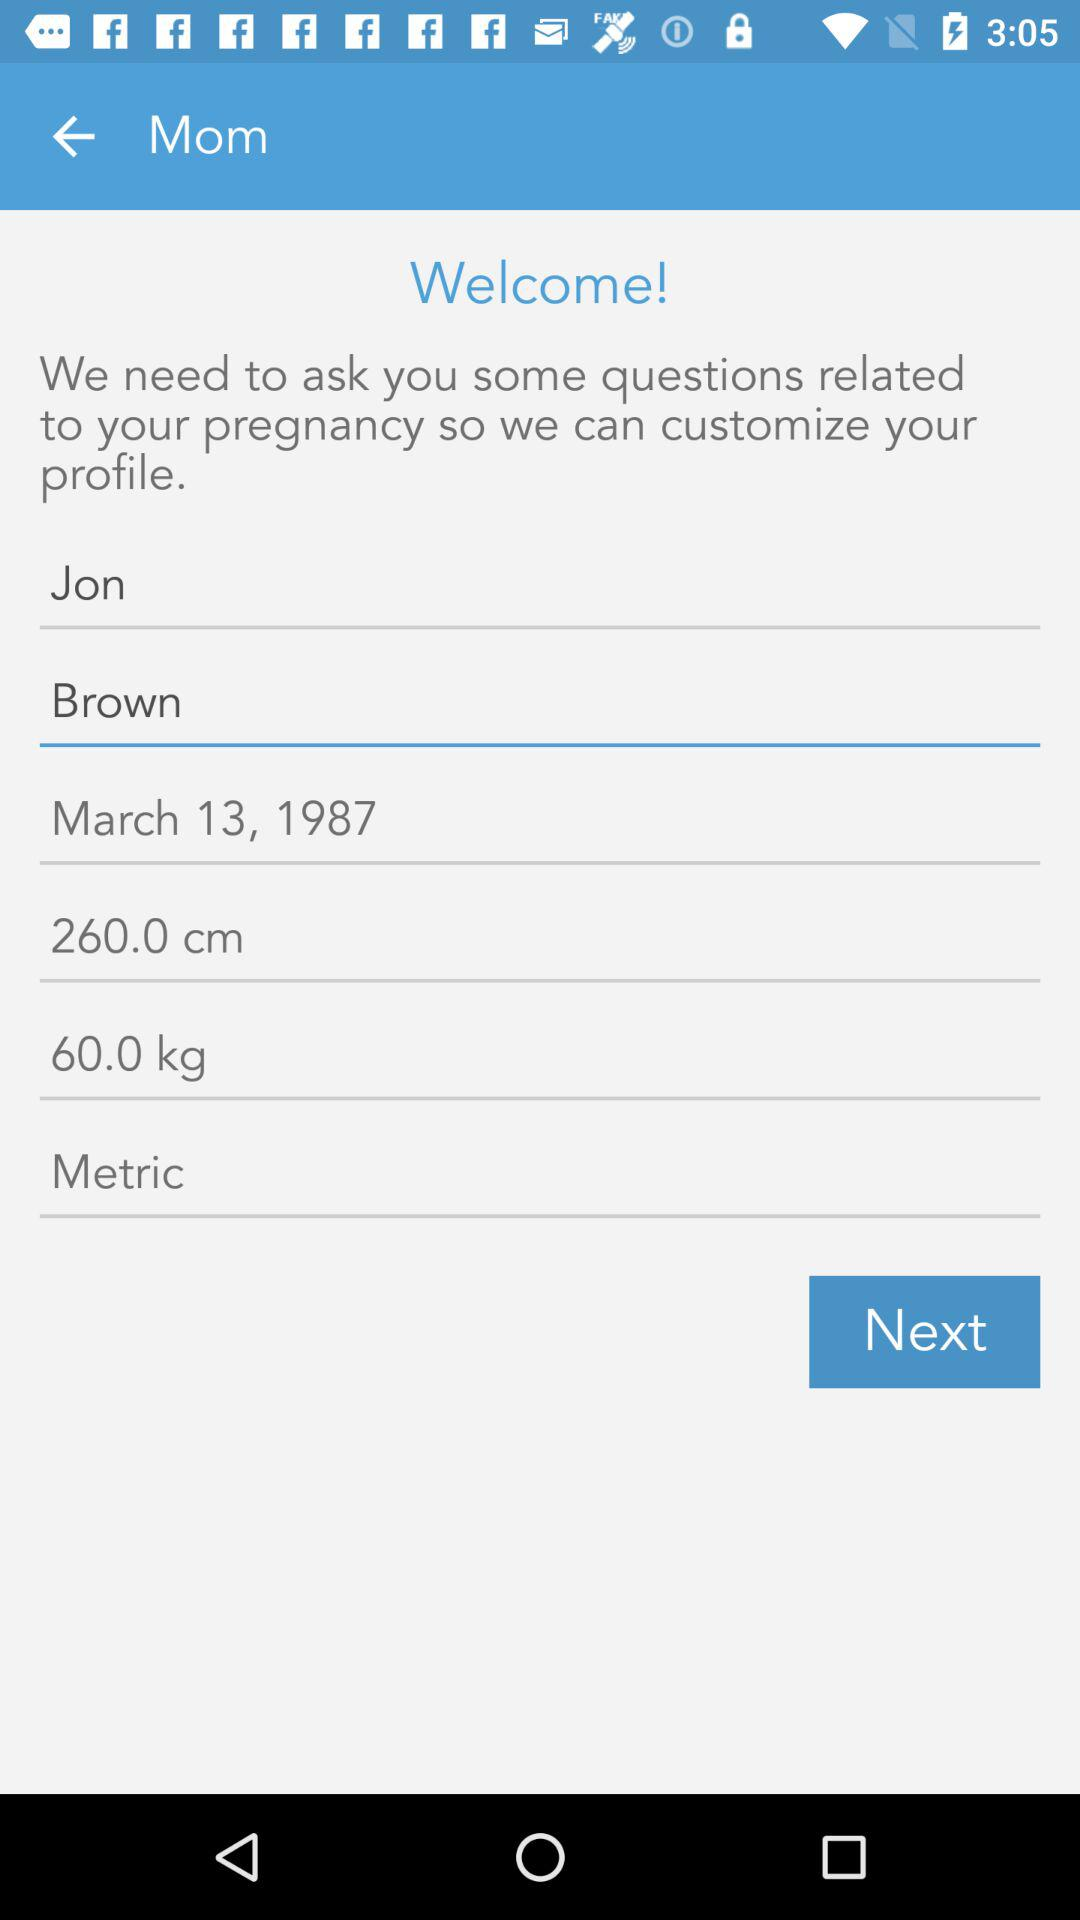What is the weight of the person? The weight of the person is 60 kg. 